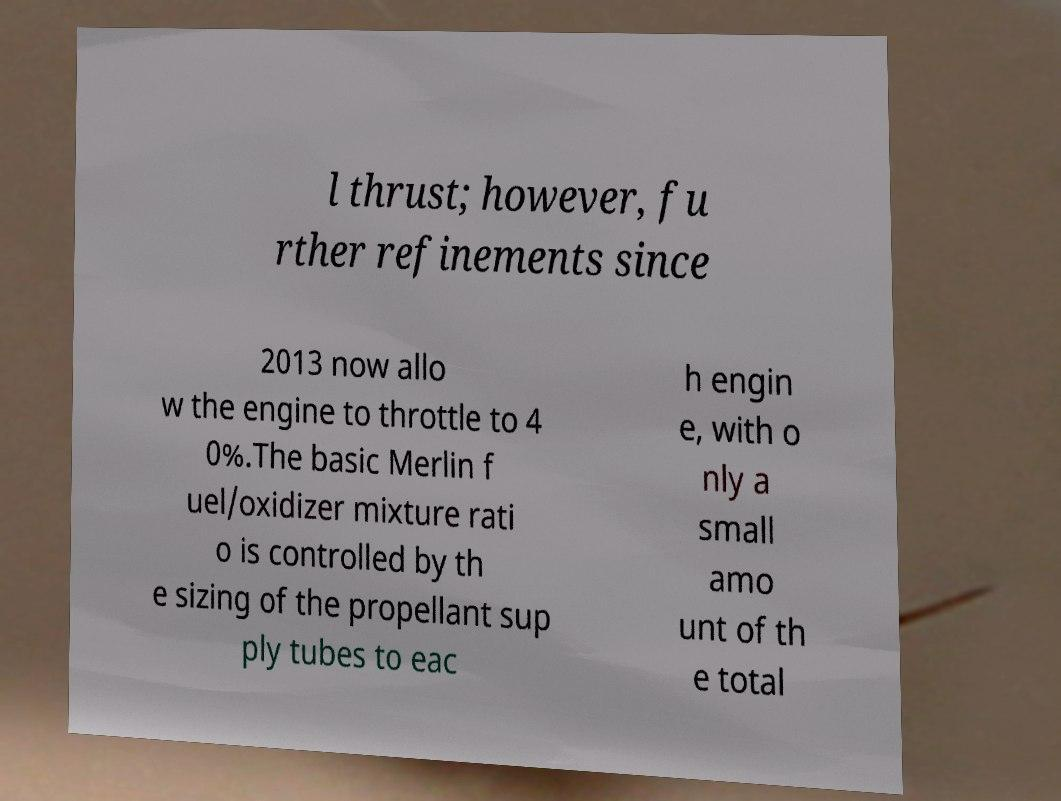Can you read and provide the text displayed in the image?This photo seems to have some interesting text. Can you extract and type it out for me? l thrust; however, fu rther refinements since 2013 now allo w the engine to throttle to 4 0%.The basic Merlin f uel/oxidizer mixture rati o is controlled by th e sizing of the propellant sup ply tubes to eac h engin e, with o nly a small amo unt of th e total 